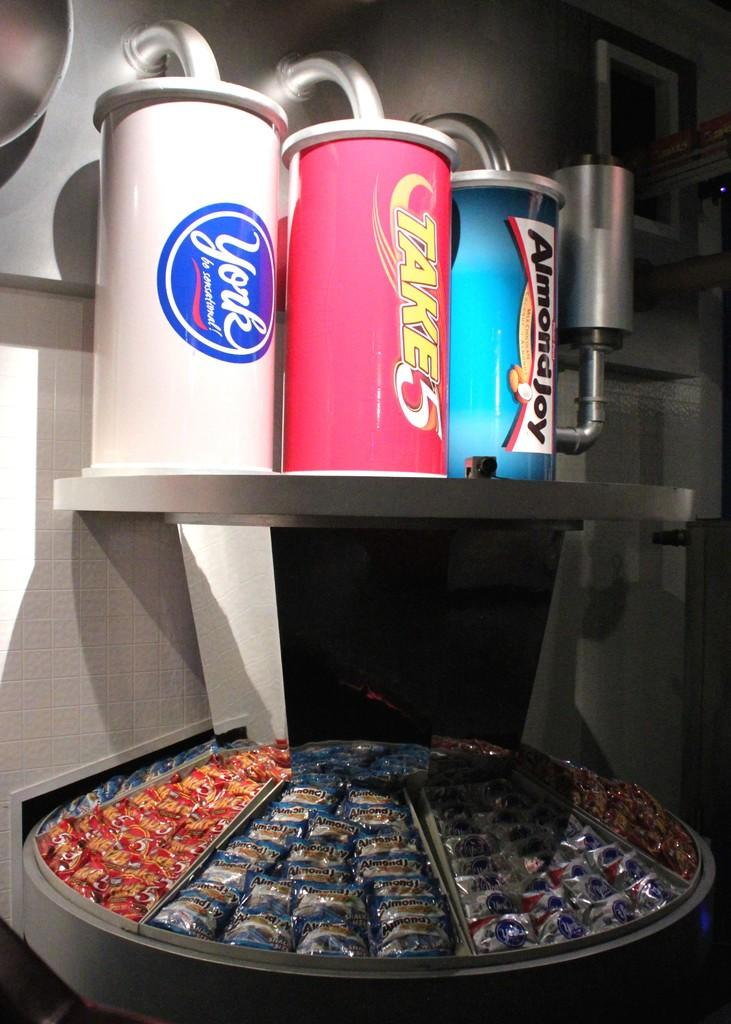<image>
Create a compact narrative representing the image presented. TAKE5, Almond Joy, and York candy bars are displayed beneath cannisters with the same name on them. 